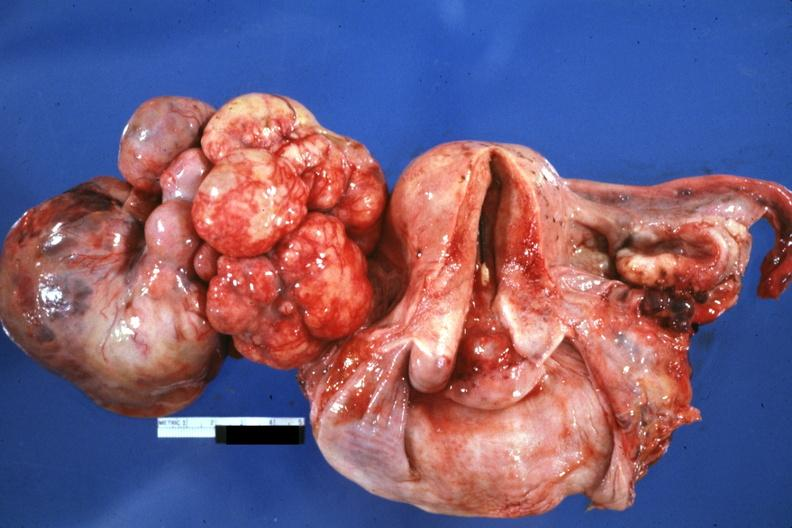s female reproductive present?
Answer the question using a single word or phrase. Yes 